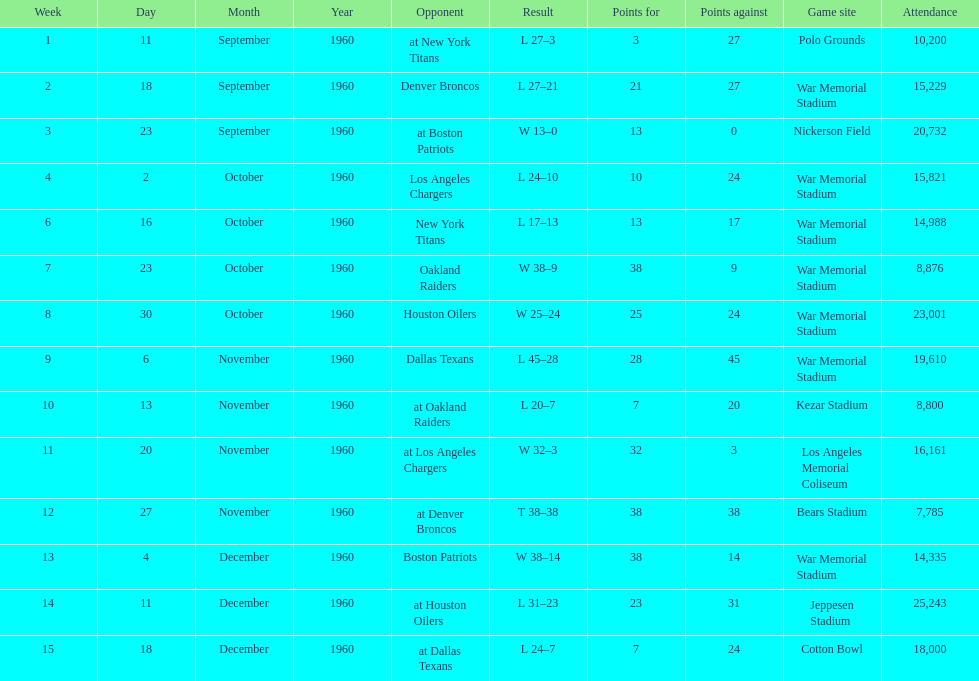Which date had the highest attendance? December 11, 1960. 